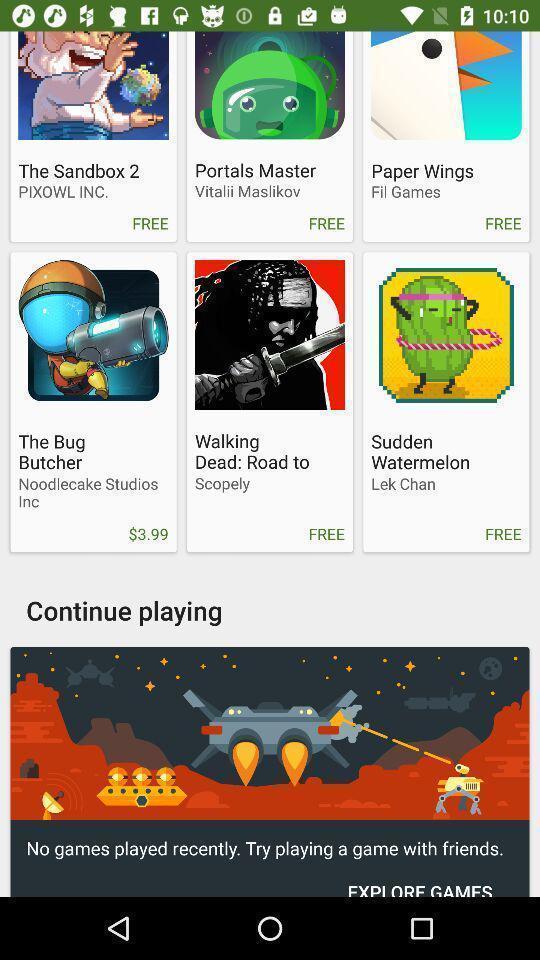Give me a summary of this screen capture. Screen shows to continue playing. 